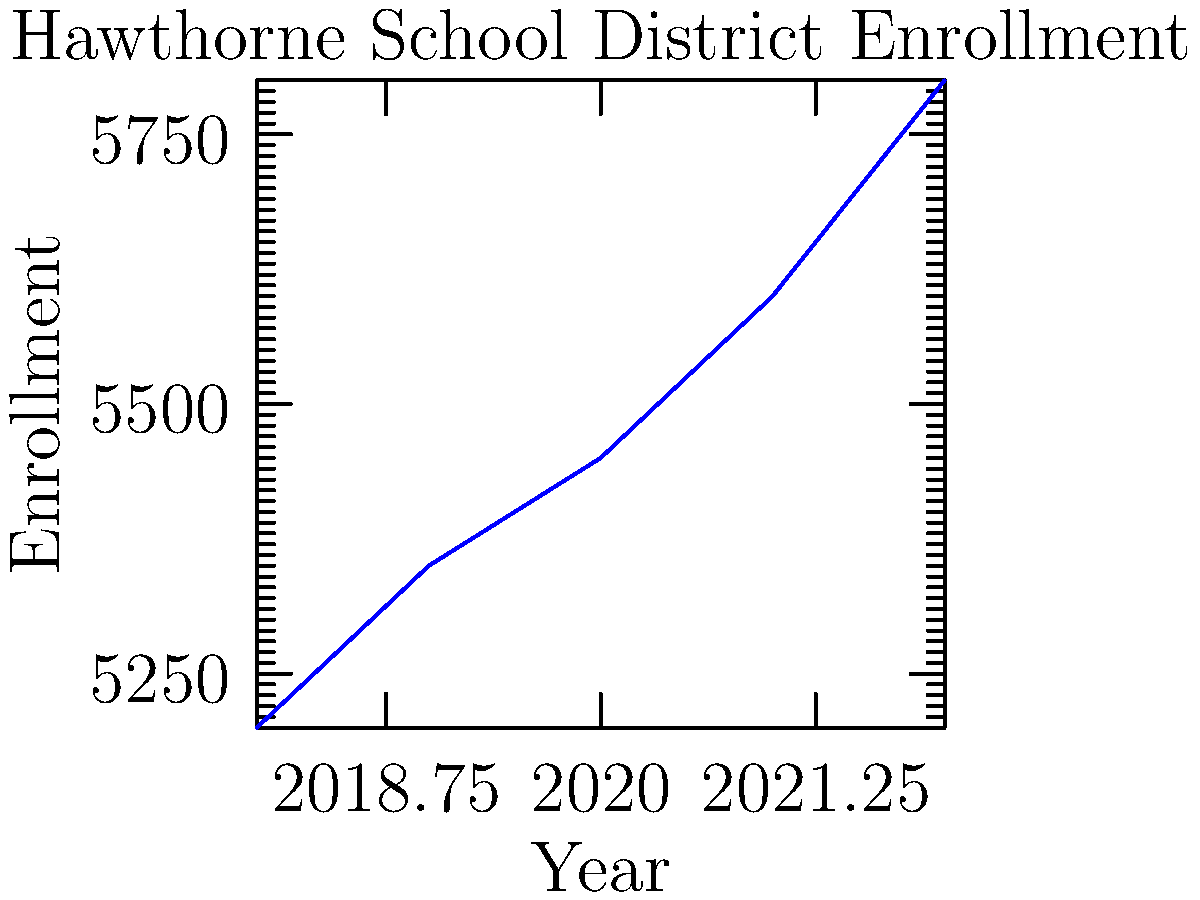Based on the line graph showing Hawthorne School District enrollment from 2018 to 2022, what was the average annual increase in student enrollment during this period? To calculate the average annual increase in student enrollment:

1. Calculate total increase: 
   $5800 - 5200 = 600$ students

2. Determine the number of years:
   $2022 - 2018 = 4$ years

3. Calculate average annual increase:
   $\frac{600 \text{ students}}{4 \text{ years}} = 150$ students per year

Therefore, the average annual increase in student enrollment was 150 students.
Answer: 150 students per year 